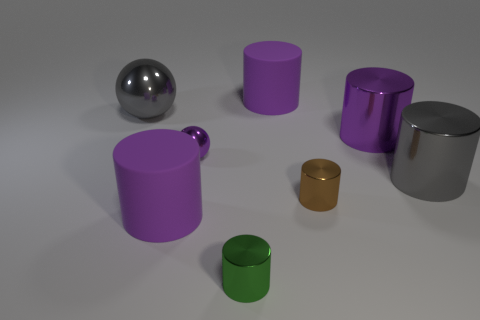What size is the metallic thing that is the same color as the small sphere?
Offer a terse response. Large. There is a large shiny thing that is on the right side of the purple shiny ball and left of the big gray cylinder; what is its color?
Provide a succinct answer. Purple. Are there any other things that are the same size as the gray cylinder?
Provide a succinct answer. Yes. There is a metallic cylinder that is right of the large purple shiny cylinder; is it the same color as the big sphere?
Your answer should be compact. Yes. What number of spheres are either green shiny objects or large gray metallic objects?
Your response must be concise. 1. What is the shape of the tiny thing that is right of the tiny green object?
Provide a succinct answer. Cylinder. There is a big cylinder in front of the gray metallic object right of the tiny metallic cylinder that is on the left side of the brown object; what color is it?
Your response must be concise. Purple. Does the big gray cylinder have the same material as the big sphere?
Your answer should be compact. Yes. How many green objects are tiny spheres or small objects?
Provide a succinct answer. 1. There is a large gray metal cylinder; how many purple rubber objects are behind it?
Make the answer very short. 1. 